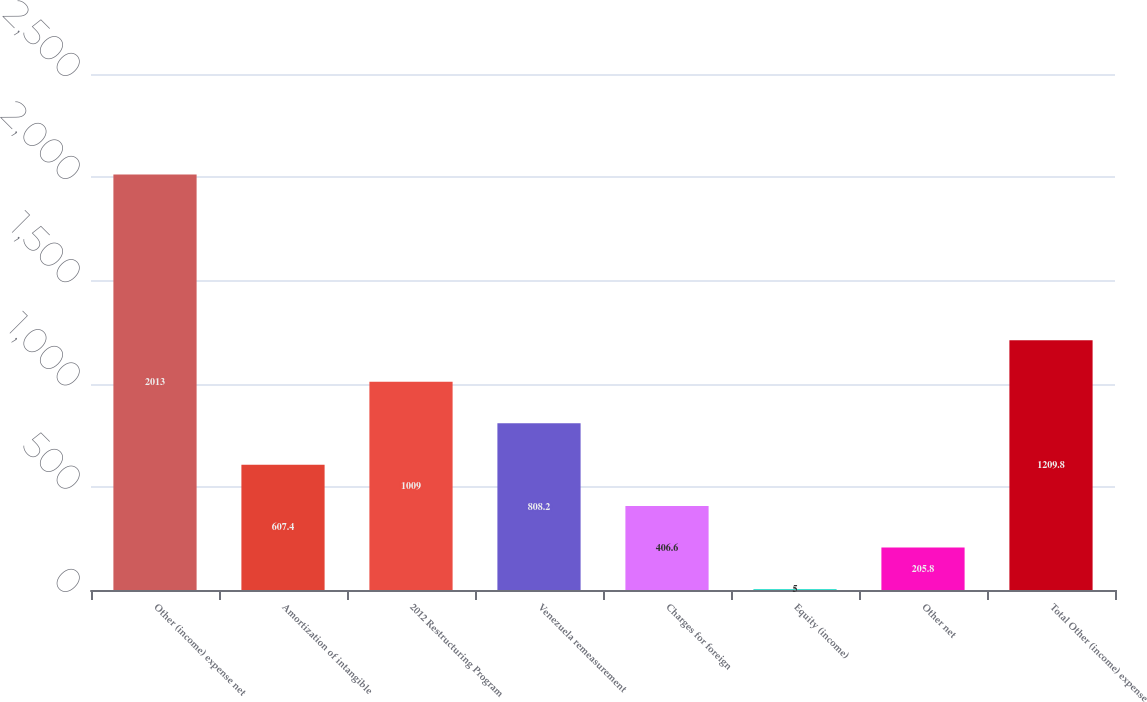Convert chart to OTSL. <chart><loc_0><loc_0><loc_500><loc_500><bar_chart><fcel>Other (income) expense net<fcel>Amortization of intangible<fcel>2012 Restructuring Program<fcel>Venezuela remeasurement<fcel>Charges for foreign<fcel>Equity (income)<fcel>Other net<fcel>Total Other (income) expense<nl><fcel>2013<fcel>607.4<fcel>1009<fcel>808.2<fcel>406.6<fcel>5<fcel>205.8<fcel>1209.8<nl></chart> 